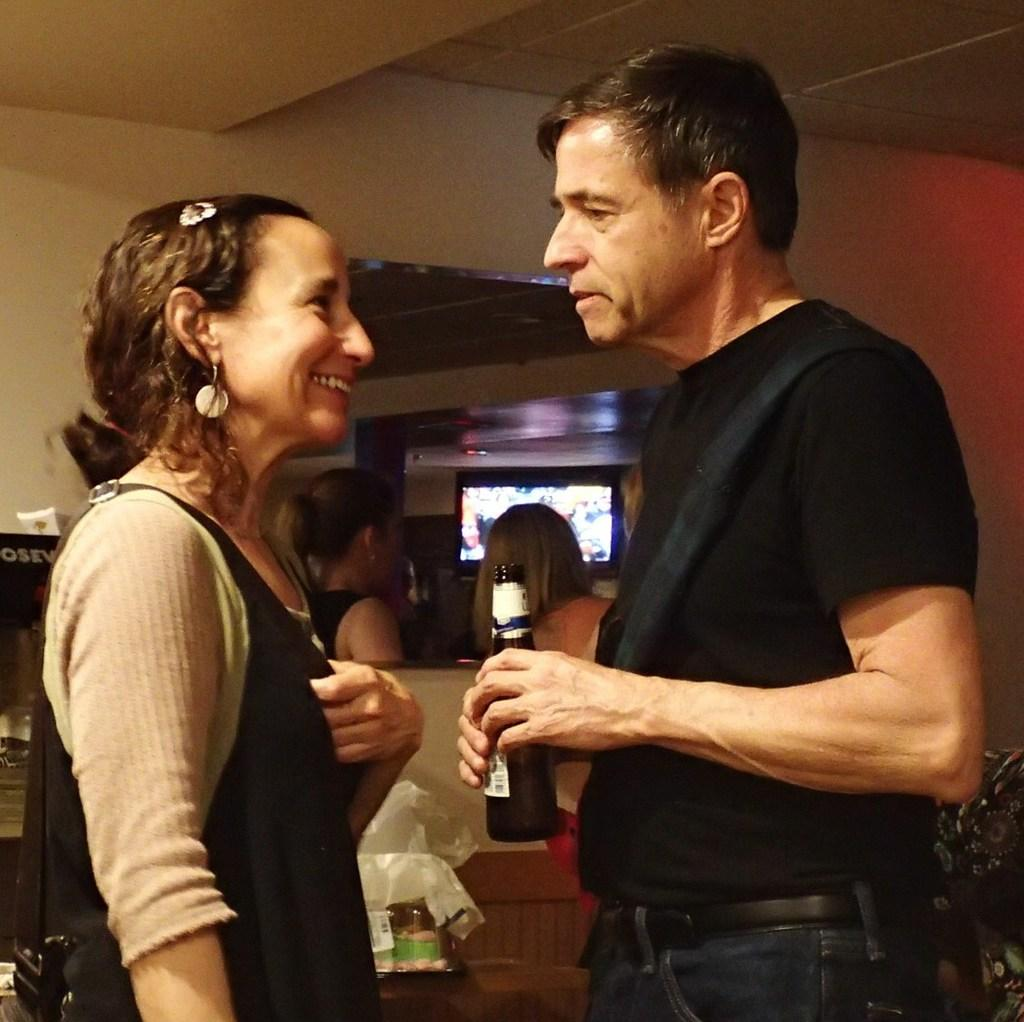What is the person in the image wearing? The person is wearing a black shirt in the image. What is the person holding in his hand? The person is holding a drink in his hand. Who is standing in front of the person? There is a woman wearing a black dress in front of the person. How many women are beside the person? There are two women beside the person. What type of haircut does the person in the image have? The provided facts do not mention the person's haircut, so we cannot determine it from the image. How does the person in the image feel about the heat? The provided facts do not mention the temperature or the person's feelings about it, so we cannot determine their opinion on the heat from the image. 